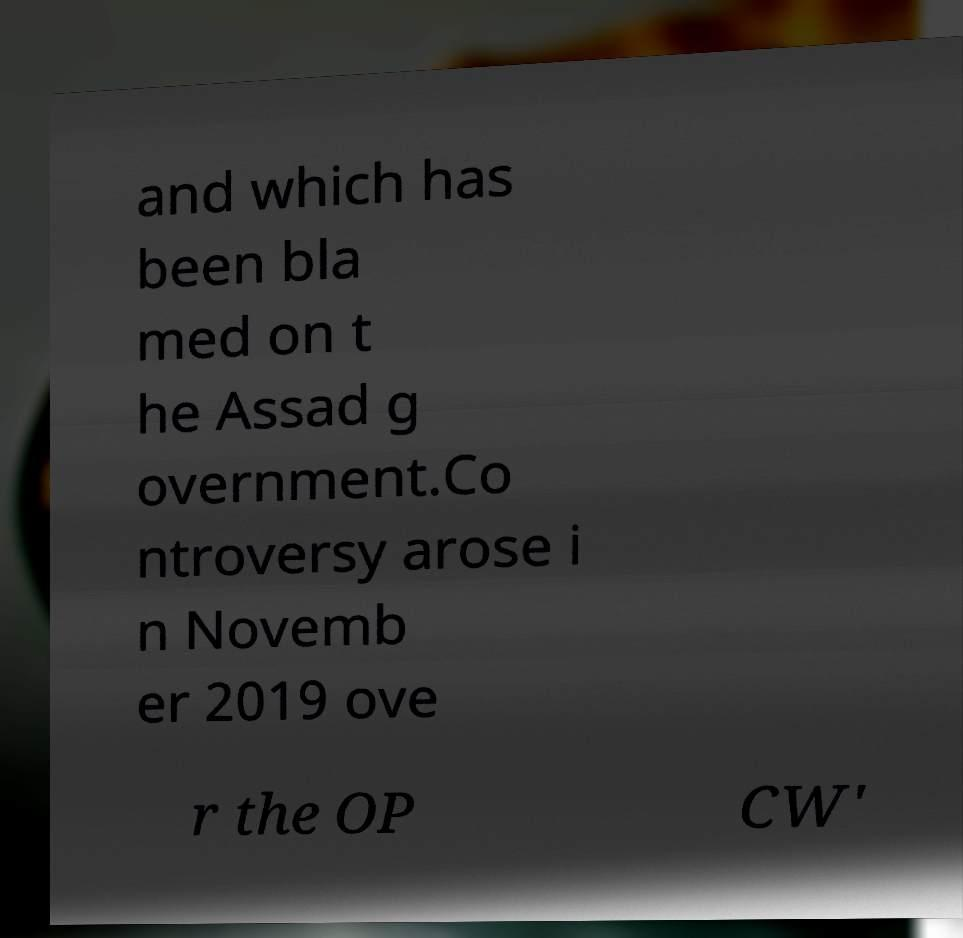For documentation purposes, I need the text within this image transcribed. Could you provide that? and which has been bla med on t he Assad g overnment.Co ntroversy arose i n Novemb er 2019 ove r the OP CW' 